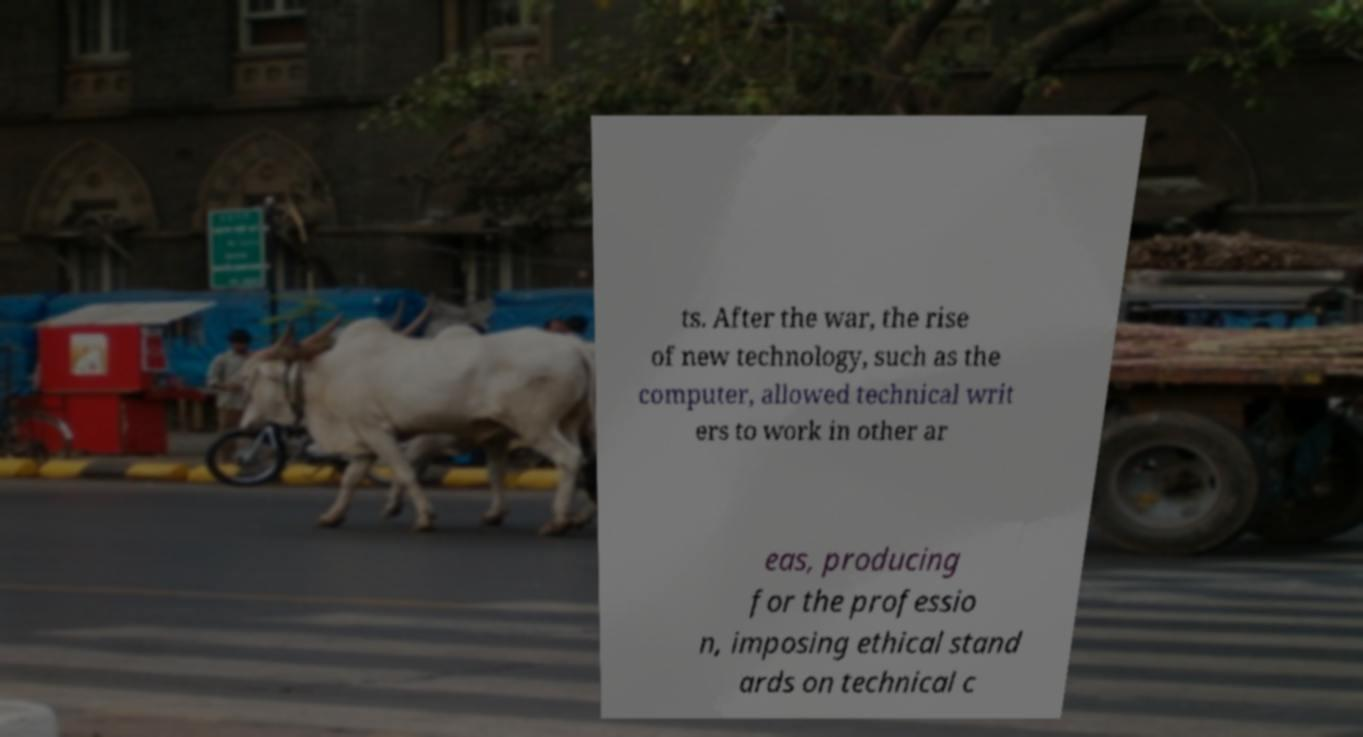Can you accurately transcribe the text from the provided image for me? ts. After the war, the rise of new technology, such as the computer, allowed technical writ ers to work in other ar eas, producing for the professio n, imposing ethical stand ards on technical c 